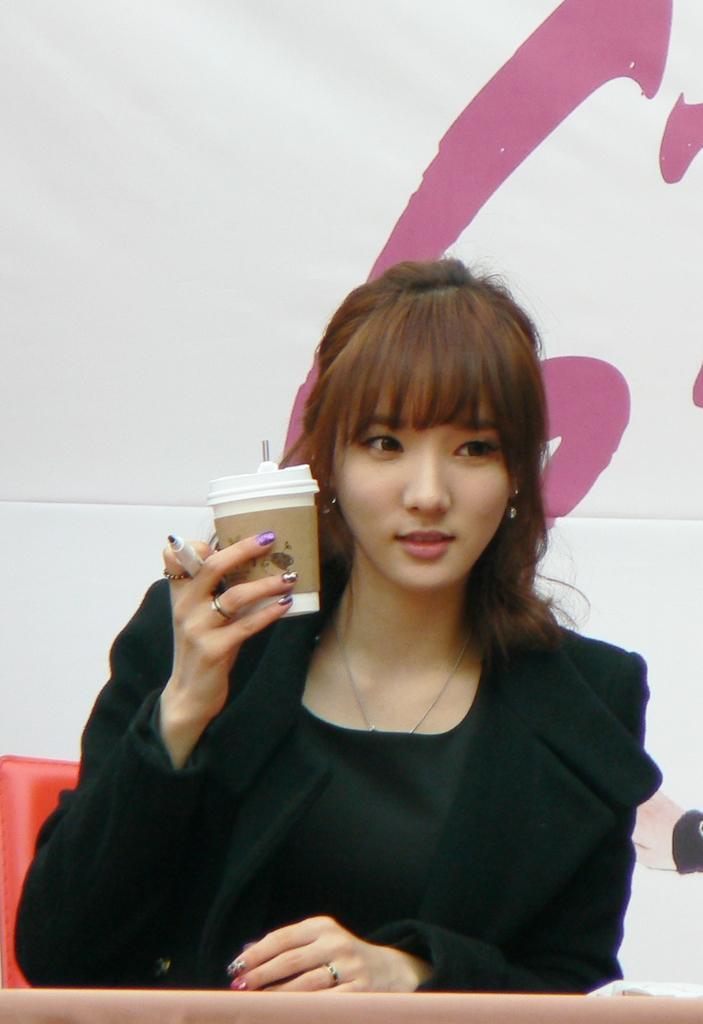Describe this image in one or two sentences. In this image we can see a girl. She is wearing black color dress and holding marker pen and glass in her hand. There is the banner in the background. 